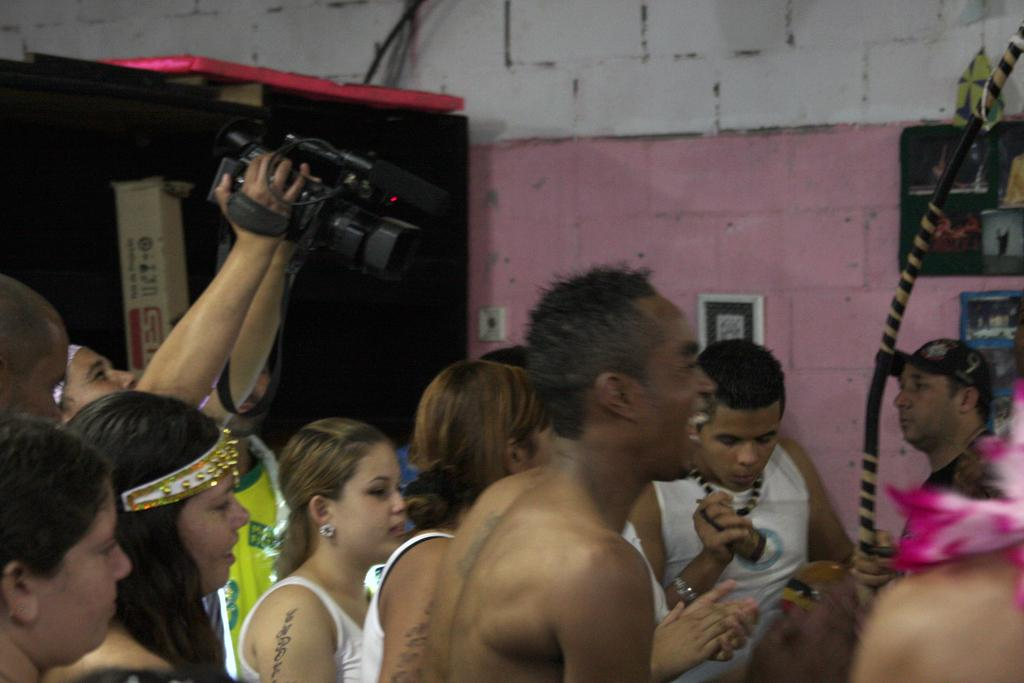How many people are in the image? There are people in the image, but the exact number is not specified. What are the people doing in the image? The people are standing and smiling in the image. Who is holding a camera in the image? There is a man holding a camera in the image. What is the man with the camera doing? The man is capturing a photo in the image. What type of guitar can be seen being played by the people in the image? There is no guitar present in the image; the people are standing and smiling, and one man is holding a camera. 